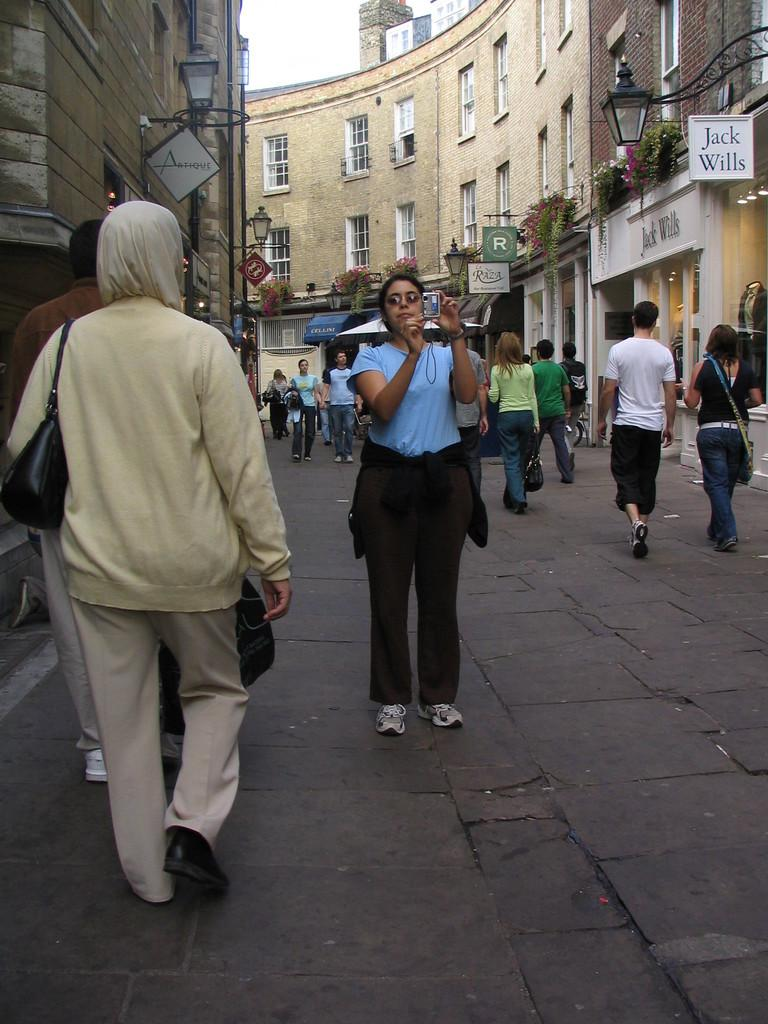Who or what can be seen in the image? There are people in the image. What else is present in the image besides people? There are plants, flowers, boards, lights, and buildings in the image. Can you describe the natural elements in the image? There are plants and flowers in the image. What is visible in the background of the image? The sky is visible in the background of the image. What is the tendency of the aunt in the image? There is no aunt present in the image, so it is not possible to determine any tendencies. 